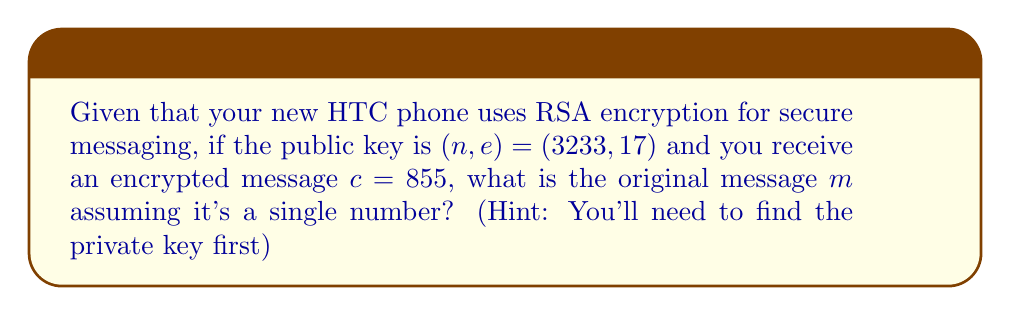Provide a solution to this math problem. To solve this problem, we need to follow these steps:

1. Find the factors of $n$:
   $3233 = 61 \times 53$

2. Calculate $\phi(n)$:
   $\phi(n) = (61-1)(53-1) = 60 \times 52 = 3120$

3. Find the private key $d$ using the modular multiplicative inverse of $e$ mod $\phi(n)$:
   $d \equiv e^{-1} \pmod{\phi(n)}$
   $17d \equiv 1 \pmod{3120}$
   Using the extended Euclidean algorithm, we find $d = 2753$

4. Decrypt the message using:
   $m \equiv c^d \pmod{n}$
   $m \equiv 855^{2753} \pmod{3233}$

5. To compute this efficiently, we can use the square-and-multiply algorithm:
   $855^{2753} \equiv 123 \pmod{3233}$

Therefore, the original message $m$ is 123.
Answer: 123 